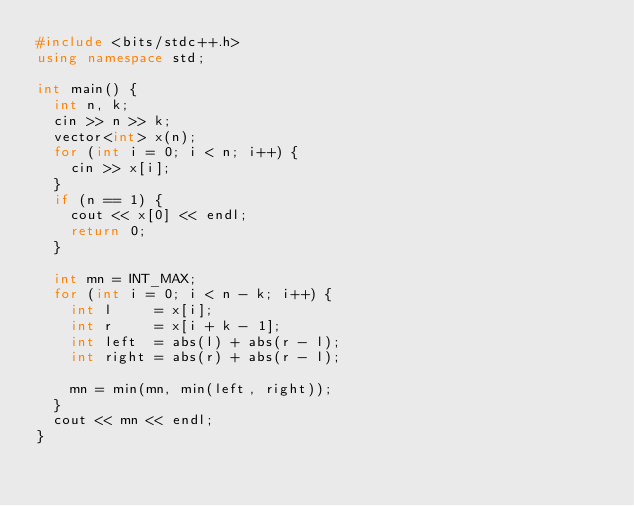<code> <loc_0><loc_0><loc_500><loc_500><_C++_>#include <bits/stdc++.h>
using namespace std;

int main() {
  int n, k;
  cin >> n >> k;
  vector<int> x(n);
  for (int i = 0; i < n; i++) {
    cin >> x[i];
  }
  if (n == 1) {
    cout << x[0] << endl;
    return 0;
  }

  int mn = INT_MAX;
  for (int i = 0; i < n - k; i++) {
    int l     = x[i];
    int r     = x[i + k - 1];
    int left  = abs(l) + abs(r - l);
    int right = abs(r) + abs(r - l);

    mn = min(mn, min(left, right));
  }
  cout << mn << endl;
}</code> 